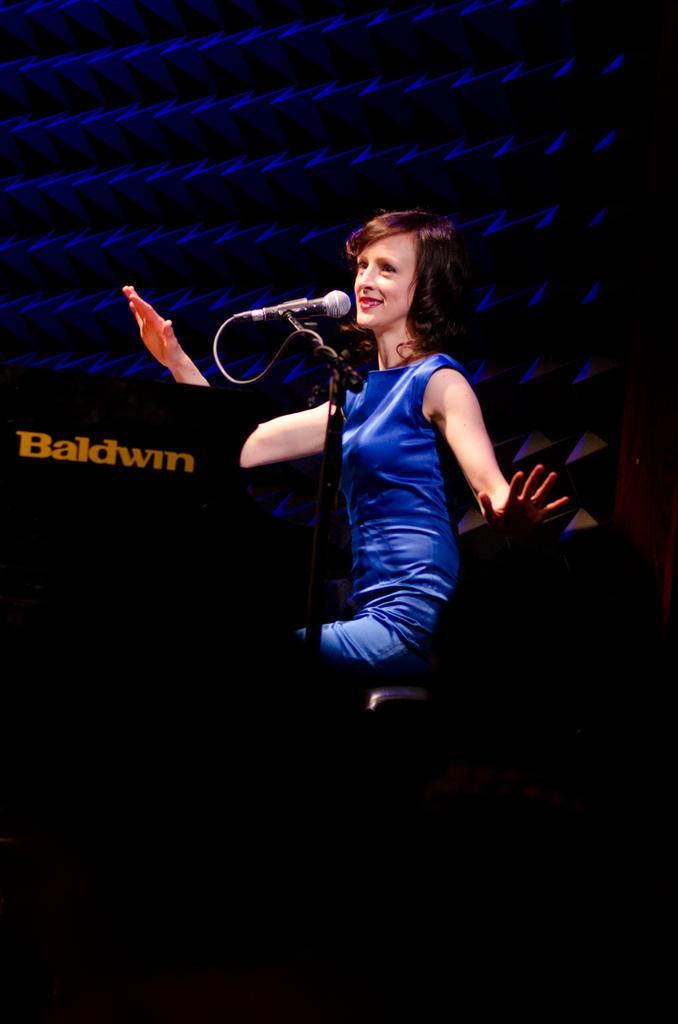In one or two sentences, can you explain what this image depicts? In the center of the image we can see there is a woman sitting on the chair. On the left side of the image we can see mic stand and mic. 